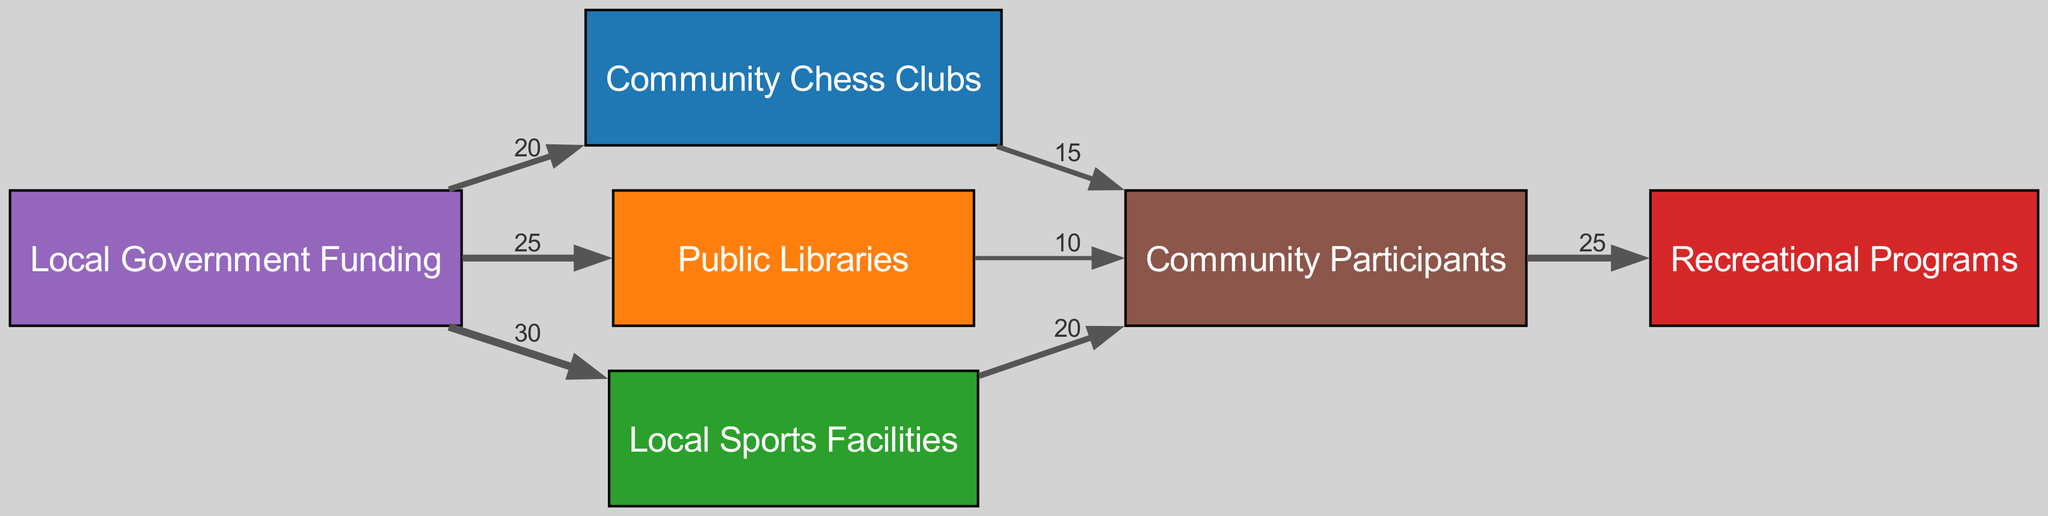What is the total funding allocated to community chess clubs? The value of funding allocated specifically to community chess clubs is indicated in the links section of the diagram as 20.
Answer: 20 How many different types of community resources are represented in the diagram? The diagram shows three types of community resources: community chess clubs, public libraries, and local sports facilities. This counts as three distinct nodes.
Answer: 3 What is the number of participants coming from the local sports facilities? The value of participants flowing from local sports facilities is shown in the diagram as 20.
Answer: 20 Which resource has the highest funding allocation? By comparing the values of funding allocated to each resource, the resource with the highest allocation is local sports facilities, with a value of 30.
Answer: Local Sports Facilities How many total community participants are being served by the programs? The total value of participants indicated flowing to the programs node from the community resources is 25.
Answer: 25 What fraction of the total funding is allocated to libraries? The funding for libraries is 25, and the total funding distributed is 75 (20 for chess clubs, 25 for libraries, 30 for sports facilities). The fraction is calculated as 25/75, which simplifies to 1/3.
Answer: 1/3 How much funding is allocated to resources that do not directly lead to participants? The funding leading to participants from chess clubs, libraries, and sports facilities is 20 + 25 + 30, summing to 75. The question focuses on direct funding without leading participants. Since all funding directly leads to participants, it is zero.
Answer: 0 What is the value of participants coming from the community chess clubs? The diagram shows that the value of participants coming from the community chess clubs is 15.
Answer: 15 